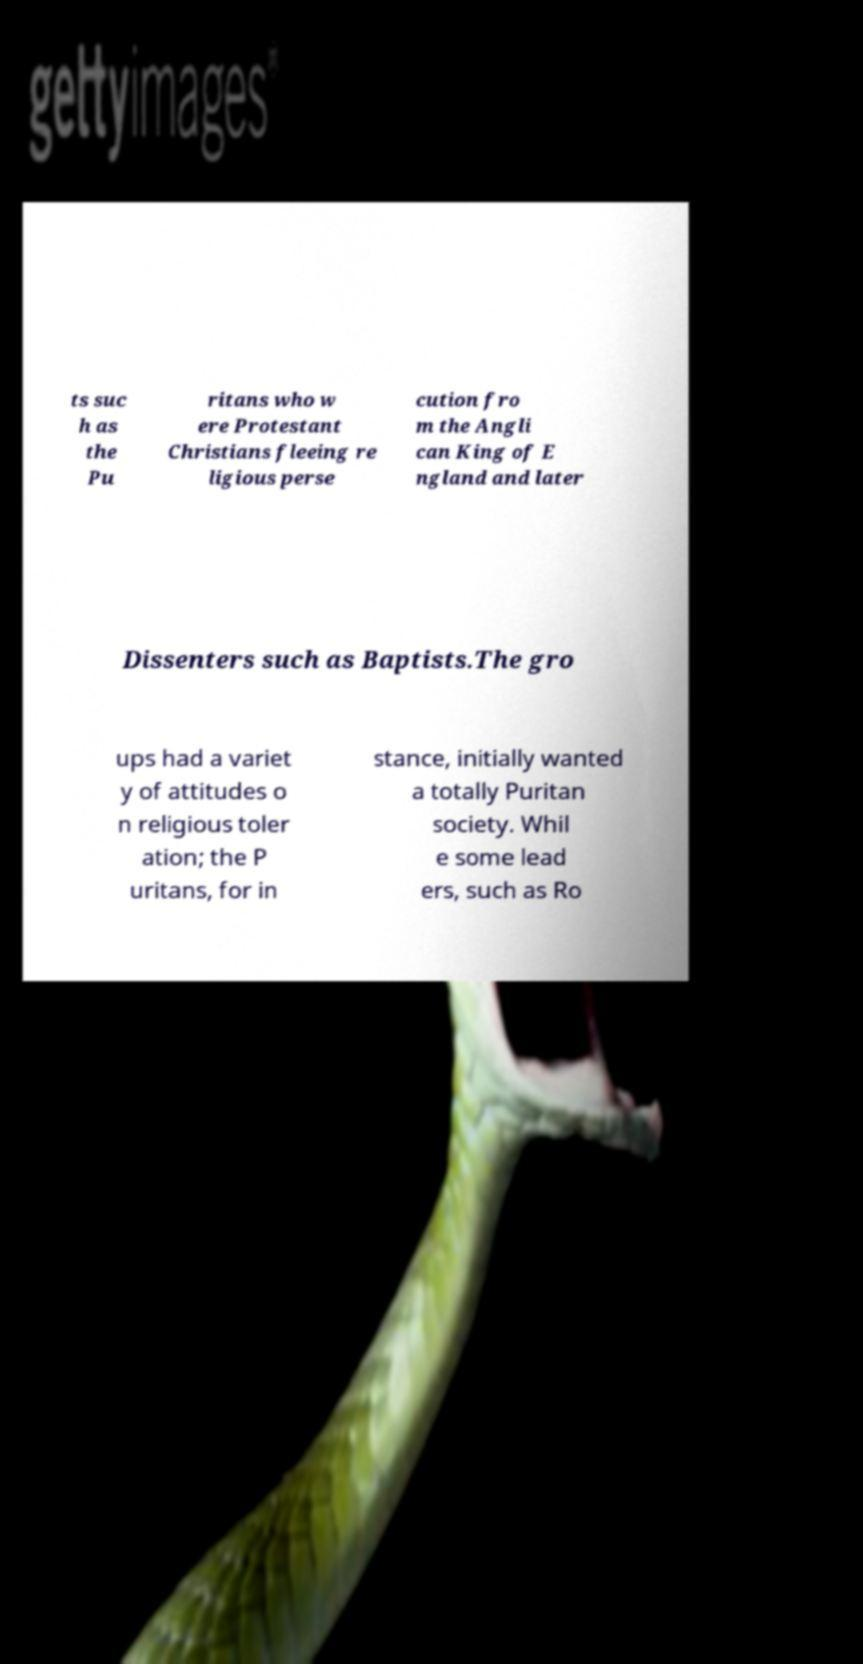What messages or text are displayed in this image? I need them in a readable, typed format. ts suc h as the Pu ritans who w ere Protestant Christians fleeing re ligious perse cution fro m the Angli can King of E ngland and later Dissenters such as Baptists.The gro ups had a variet y of attitudes o n religious toler ation; the P uritans, for in stance, initially wanted a totally Puritan society. Whil e some lead ers, such as Ro 